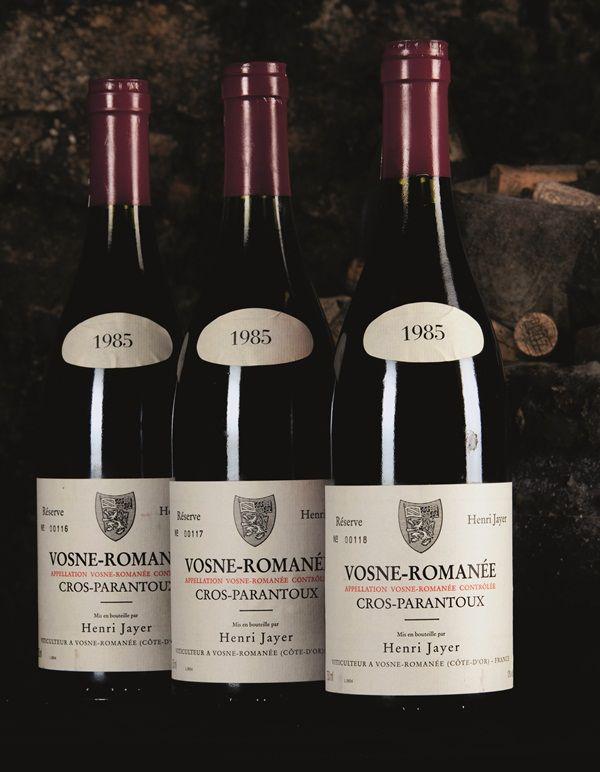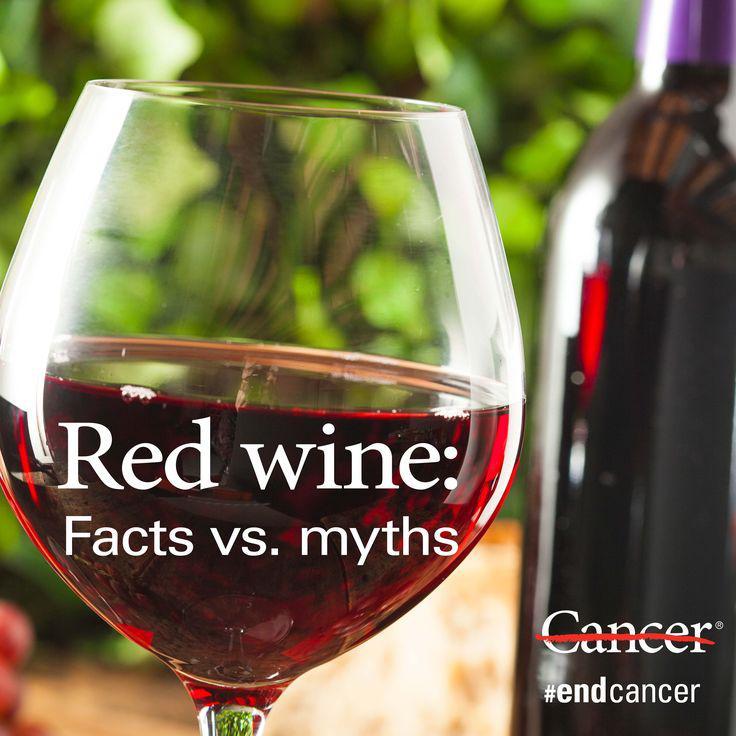The first image is the image on the left, the second image is the image on the right. For the images displayed, is the sentence "there is a half filled wine glas next to a wine bottle" factually correct? Answer yes or no. Yes. 